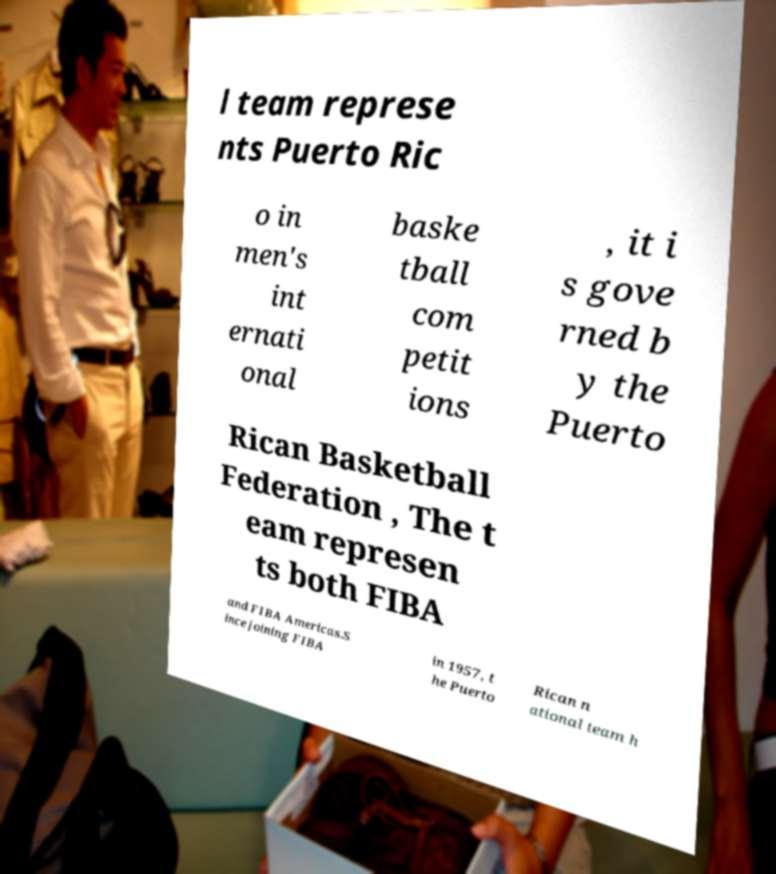Can you accurately transcribe the text from the provided image for me? l team represe nts Puerto Ric o in men's int ernati onal baske tball com petit ions , it i s gove rned b y the Puerto Rican Basketball Federation , The t eam represen ts both FIBA and FIBA Americas.S ince joining FIBA in 1957, t he Puerto Rican n ational team h 